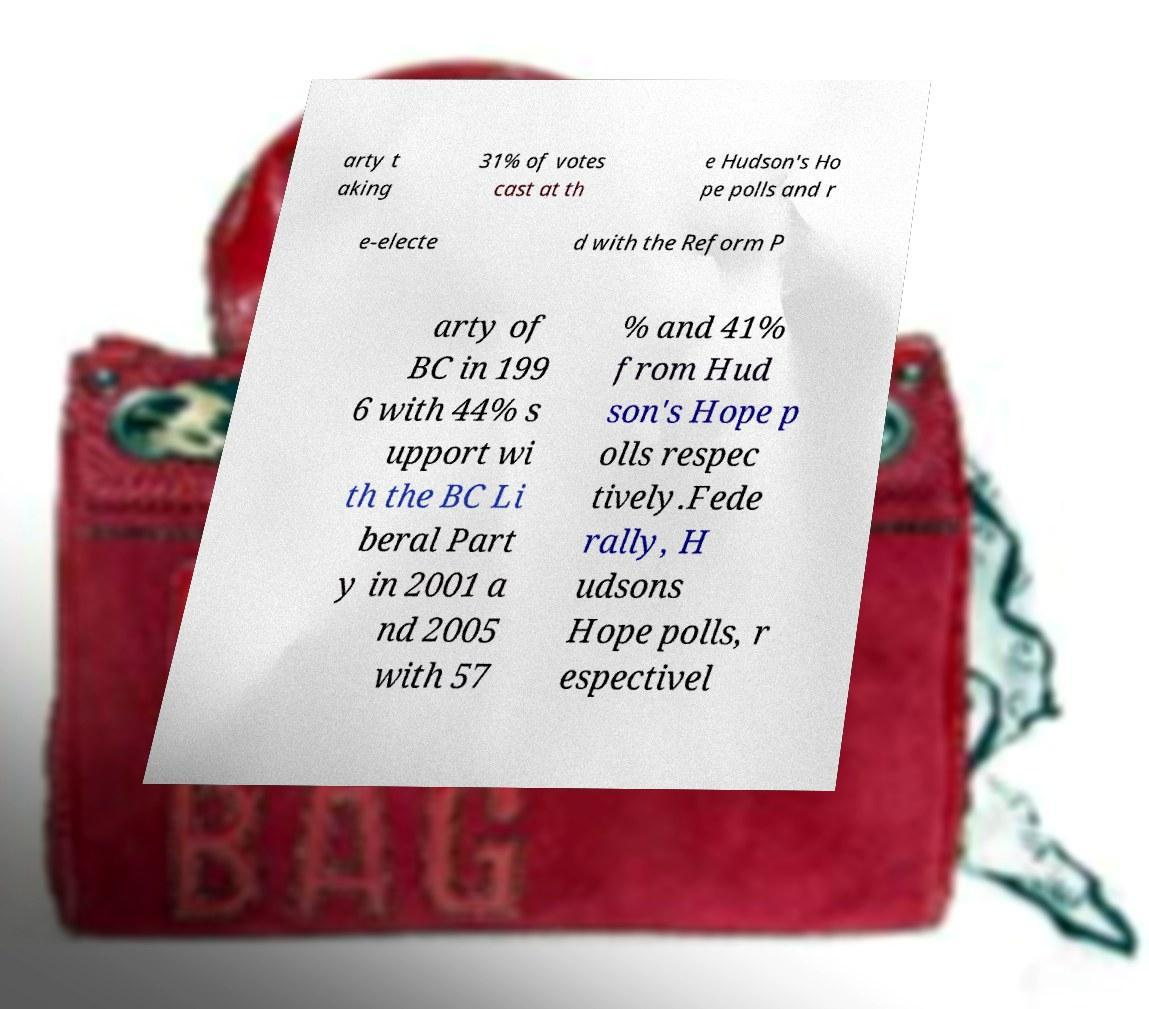Could you assist in decoding the text presented in this image and type it out clearly? arty t aking 31% of votes cast at th e Hudson's Ho pe polls and r e-electe d with the Reform P arty of BC in 199 6 with 44% s upport wi th the BC Li beral Part y in 2001 a nd 2005 with 57 % and 41% from Hud son's Hope p olls respec tively.Fede rally, H udsons Hope polls, r espectivel 